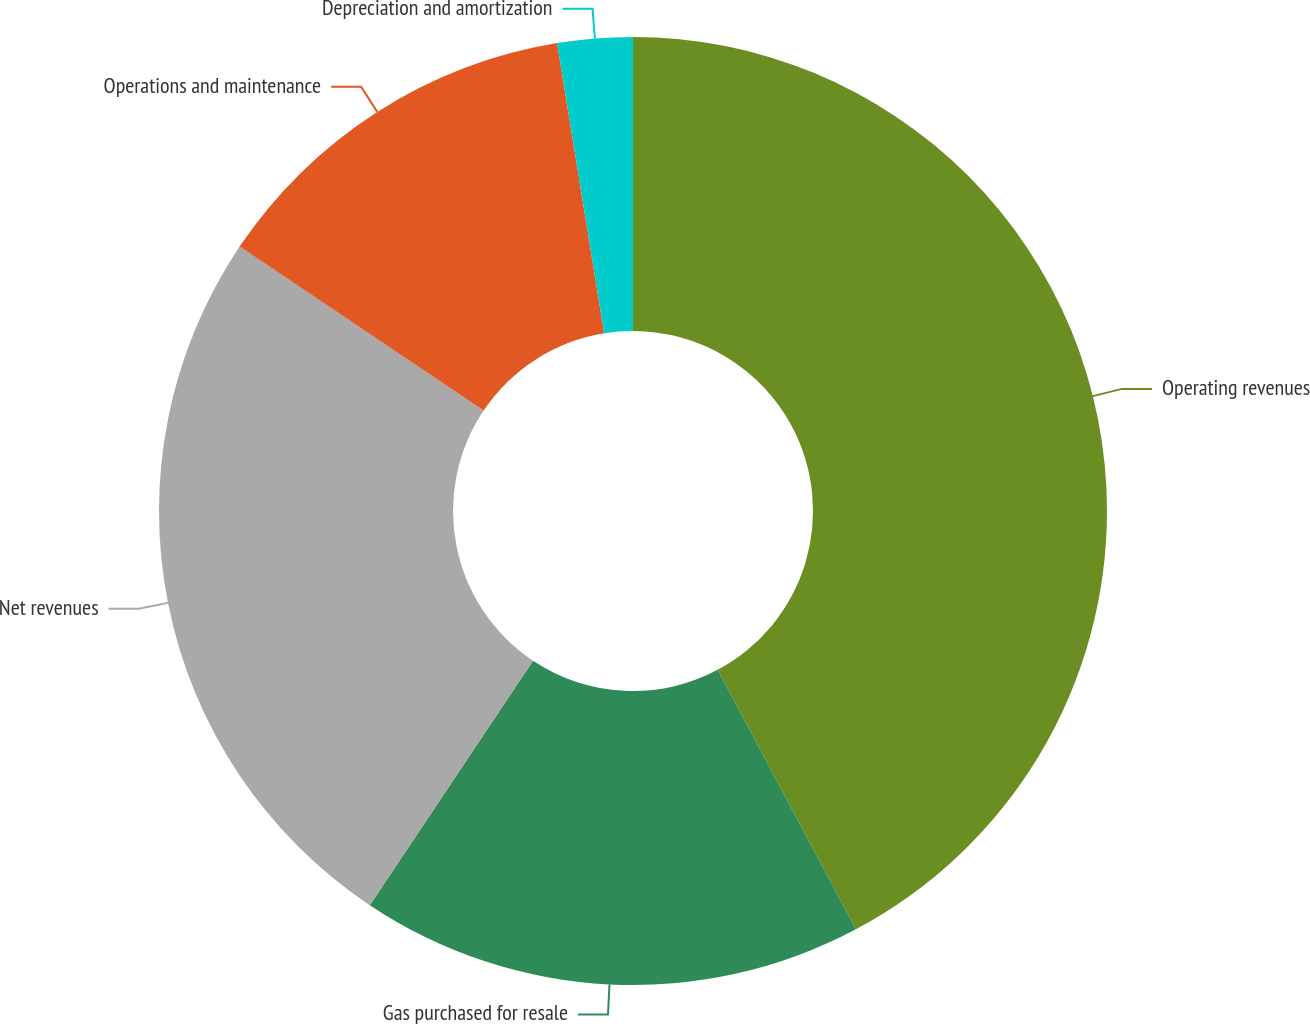Convert chart. <chart><loc_0><loc_0><loc_500><loc_500><pie_chart><fcel>Operating revenues<fcel>Gas purchased for resale<fcel>Net revenues<fcel>Operations and maintenance<fcel>Depreciation and amortization<nl><fcel>42.21%<fcel>17.16%<fcel>25.05%<fcel>13.02%<fcel>2.56%<nl></chart> 